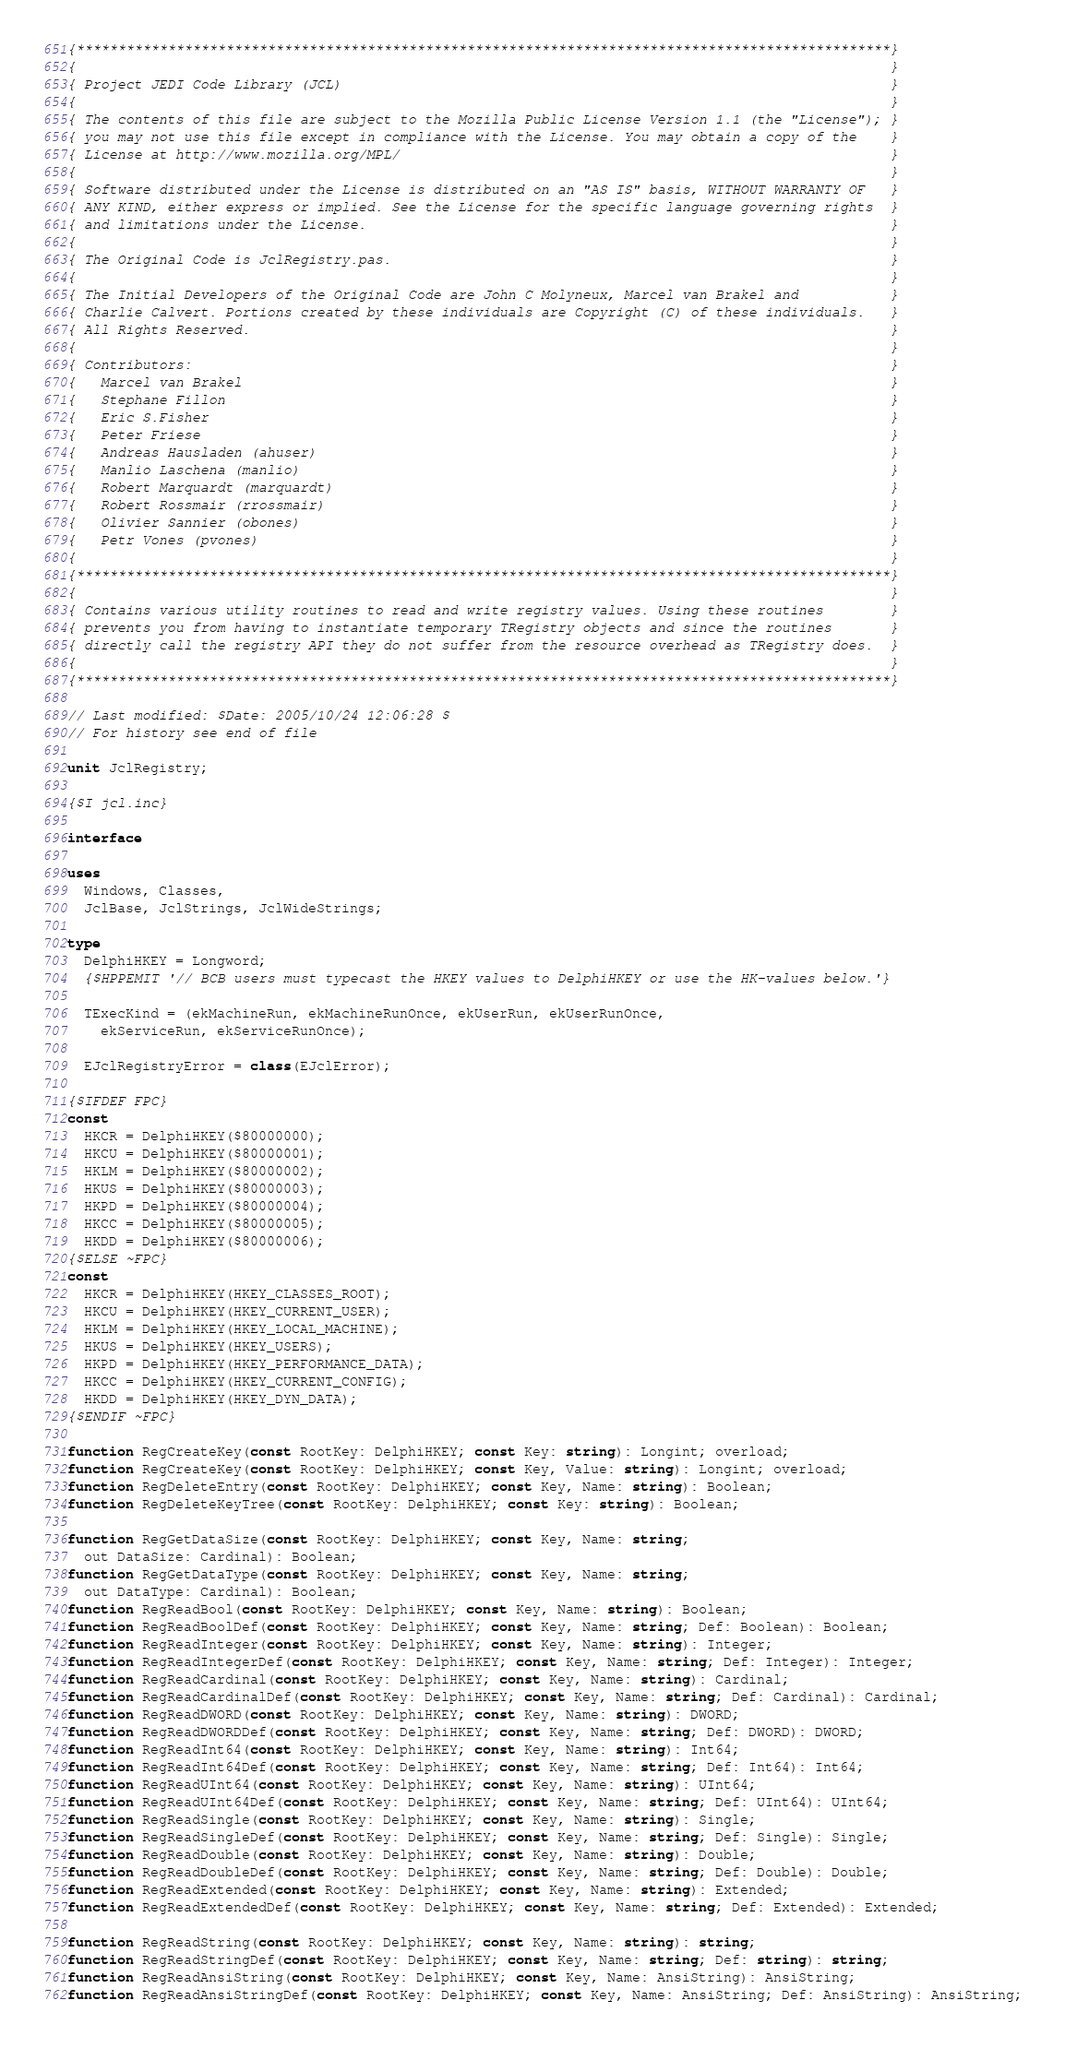Convert code to text. <code><loc_0><loc_0><loc_500><loc_500><_Pascal_>{**************************************************************************************************}
{                                                                                                  }
{ Project JEDI Code Library (JCL)                                                                  }
{                                                                                                  }
{ The contents of this file are subject to the Mozilla Public License Version 1.1 (the "License"); }
{ you may not use this file except in compliance with the License. You may obtain a copy of the    }
{ License at http://www.mozilla.org/MPL/                                                           }
{                                                                                                  }
{ Software distributed under the License is distributed on an "AS IS" basis, WITHOUT WARRANTY OF   }
{ ANY KIND, either express or implied. See the License for the specific language governing rights  }
{ and limitations under the License.                                                               }
{                                                                                                  }
{ The Original Code is JclRegistry.pas.                                                            }
{                                                                                                  }
{ The Initial Developers of the Original Code are John C Molyneux, Marcel van Brakel and           }
{ Charlie Calvert. Portions created by these individuals are Copyright (C) of these individuals.   }
{ All Rights Reserved.                                                                             }
{                                                                                                  }
{ Contributors:                                                                                    }
{   Marcel van Brakel                                                                              }
{   Stephane Fillon                                                                                }
{   Eric S.Fisher                                                                                  }
{   Peter Friese                                                                                   }
{   Andreas Hausladen (ahuser)                                                                     }
{   Manlio Laschena (manlio)                                                                       }
{   Robert Marquardt (marquardt)                                                                   }
{   Robert Rossmair (rrossmair)                                                                    }
{   Olivier Sannier (obones)                                                                       }
{   Petr Vones (pvones)                                                                            }
{                                                                                                  }
{**************************************************************************************************}
{                                                                                                  }
{ Contains various utility routines to read and write registry values. Using these routines        }
{ prevents you from having to instantiate temporary TRegistry objects and since the routines       }
{ directly call the registry API they do not suffer from the resource overhead as TRegistry does.  }
{                                                                                                  }
{**************************************************************************************************}

// Last modified: $Date: 2005/10/24 12:06:28 $
// For history see end of file

unit JclRegistry;

{$I jcl.inc}

interface

uses
  Windows, Classes,
  JclBase, JclStrings, JclWideStrings;

type
  DelphiHKEY = Longword;
  {$HPPEMIT '// BCB users must typecast the HKEY values to DelphiHKEY or use the HK-values below.'}

  TExecKind = (ekMachineRun, ekMachineRunOnce, ekUserRun, ekUserRunOnce,
    ekServiceRun, ekServiceRunOnce);

  EJclRegistryError = class(EJclError);

{$IFDEF FPC}
const
  HKCR = DelphiHKEY($80000000);
  HKCU = DelphiHKEY($80000001);
  HKLM = DelphiHKEY($80000002);
  HKUS = DelphiHKEY($80000003);
  HKPD = DelphiHKEY($80000004);
  HKCC = DelphiHKEY($80000005);
  HKDD = DelphiHKEY($80000006);
{$ELSE ~FPC}
const
  HKCR = DelphiHKEY(HKEY_CLASSES_ROOT);
  HKCU = DelphiHKEY(HKEY_CURRENT_USER);
  HKLM = DelphiHKEY(HKEY_LOCAL_MACHINE);
  HKUS = DelphiHKEY(HKEY_USERS);
  HKPD = DelphiHKEY(HKEY_PERFORMANCE_DATA);
  HKCC = DelphiHKEY(HKEY_CURRENT_CONFIG);
  HKDD = DelphiHKEY(HKEY_DYN_DATA);
{$ENDIF ~FPC}

function RegCreateKey(const RootKey: DelphiHKEY; const Key: string): Longint; overload;
function RegCreateKey(const RootKey: DelphiHKEY; const Key, Value: string): Longint; overload;
function RegDeleteEntry(const RootKey: DelphiHKEY; const Key, Name: string): Boolean;
function RegDeleteKeyTree(const RootKey: DelphiHKEY; const Key: string): Boolean;

function RegGetDataSize(const RootKey: DelphiHKEY; const Key, Name: string;
  out DataSize: Cardinal): Boolean;
function RegGetDataType(const RootKey: DelphiHKEY; const Key, Name: string;
  out DataType: Cardinal): Boolean;
function RegReadBool(const RootKey: DelphiHKEY; const Key, Name: string): Boolean;
function RegReadBoolDef(const RootKey: DelphiHKEY; const Key, Name: string; Def: Boolean): Boolean;
function RegReadInteger(const RootKey: DelphiHKEY; const Key, Name: string): Integer;
function RegReadIntegerDef(const RootKey: DelphiHKEY; const Key, Name: string; Def: Integer): Integer;
function RegReadCardinal(const RootKey: DelphiHKEY; const Key, Name: string): Cardinal;
function RegReadCardinalDef(const RootKey: DelphiHKEY; const Key, Name: string; Def: Cardinal): Cardinal;
function RegReadDWORD(const RootKey: DelphiHKEY; const Key, Name: string): DWORD;
function RegReadDWORDDef(const RootKey: DelphiHKEY; const Key, Name: string; Def: DWORD): DWORD;
function RegReadInt64(const RootKey: DelphiHKEY; const Key, Name: string): Int64;
function RegReadInt64Def(const RootKey: DelphiHKEY; const Key, Name: string; Def: Int64): Int64;
function RegReadUInt64(const RootKey: DelphiHKEY; const Key, Name: string): UInt64;
function RegReadUInt64Def(const RootKey: DelphiHKEY; const Key, Name: string; Def: UInt64): UInt64;
function RegReadSingle(const RootKey: DelphiHKEY; const Key, Name: string): Single;
function RegReadSingleDef(const RootKey: DelphiHKEY; const Key, Name: string; Def: Single): Single;
function RegReadDouble(const RootKey: DelphiHKEY; const Key, Name: string): Double;
function RegReadDoubleDef(const RootKey: DelphiHKEY; const Key, Name: string; Def: Double): Double;
function RegReadExtended(const RootKey: DelphiHKEY; const Key, Name: string): Extended;
function RegReadExtendedDef(const RootKey: DelphiHKEY; const Key, Name: string; Def: Extended): Extended;

function RegReadString(const RootKey: DelphiHKEY; const Key, Name: string): string;
function RegReadStringDef(const RootKey: DelphiHKEY; const Key, Name: string; Def: string): string;
function RegReadAnsiString(const RootKey: DelphiHKEY; const Key, Name: AnsiString): AnsiString;
function RegReadAnsiStringDef(const RootKey: DelphiHKEY; const Key, Name: AnsiString; Def: AnsiString): AnsiString;</code> 